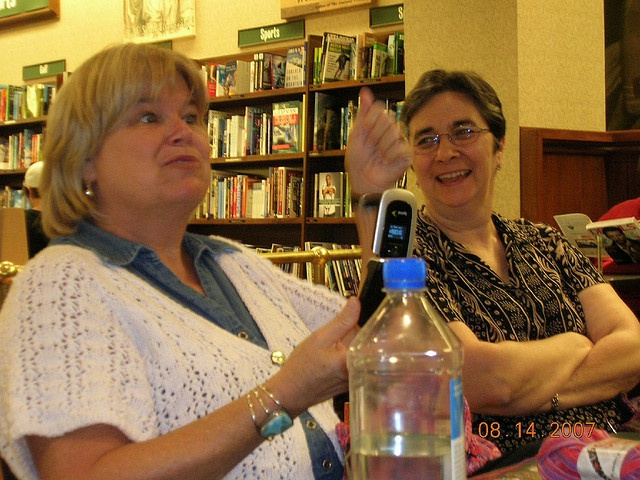Describe the objects in this image and their specific colors. I can see people in lightyellow, tan, brown, and maroon tones, people in lightyellow, brown, black, and maroon tones, book in lightyellow, black, olive, and tan tones, bottle in lightyellow, gray, and brown tones, and cell phone in lightyellow, black, gray, and olive tones in this image. 